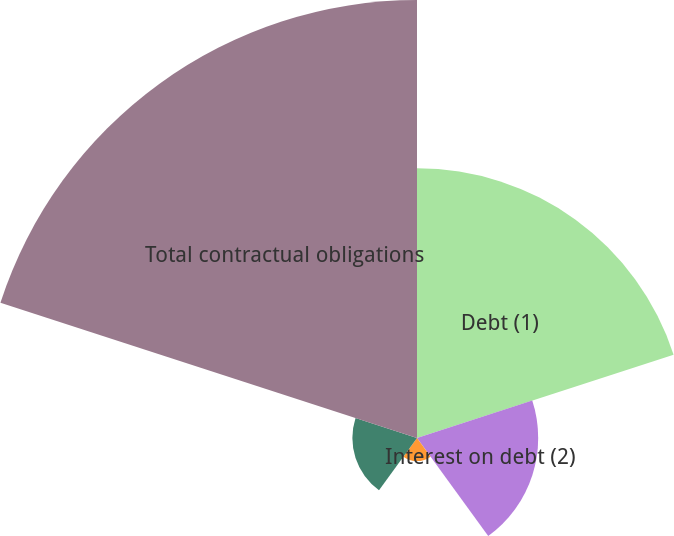<chart> <loc_0><loc_0><loc_500><loc_500><pie_chart><fcel>Debt (1)<fcel>Interest on debt (2)<fcel>Operating lease obligations<fcel>Purchase obligations (4)<fcel>Total contractual obligations<nl><fcel>29.43%<fcel>13.22%<fcel>2.52%<fcel>7.05%<fcel>47.78%<nl></chart> 